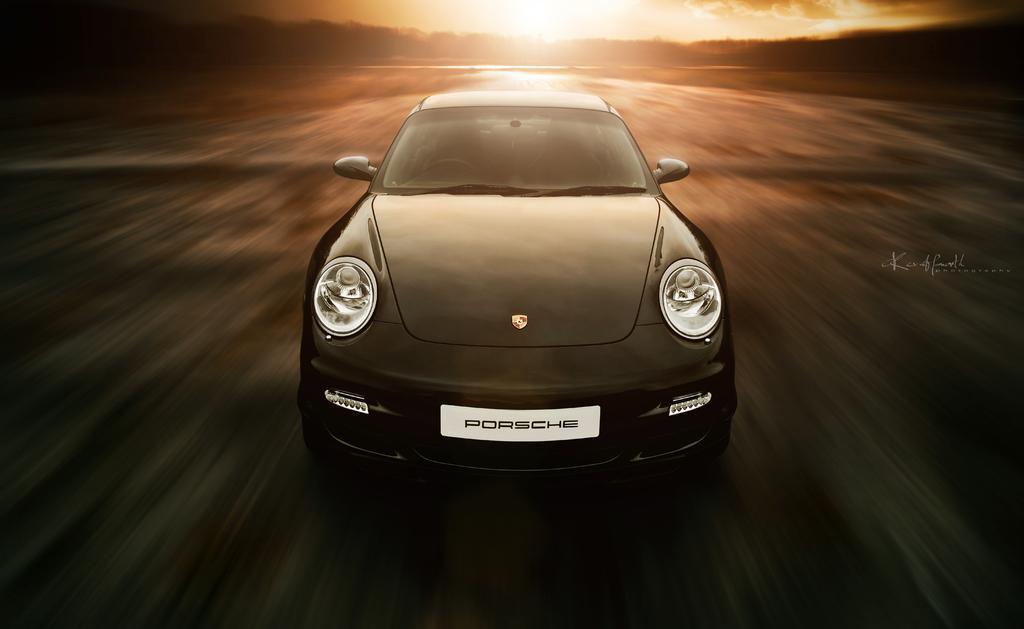Please provide a concise description of this image. In this image I can see the vehicle on the road. In the background I can see many trees, sun and the sky. 